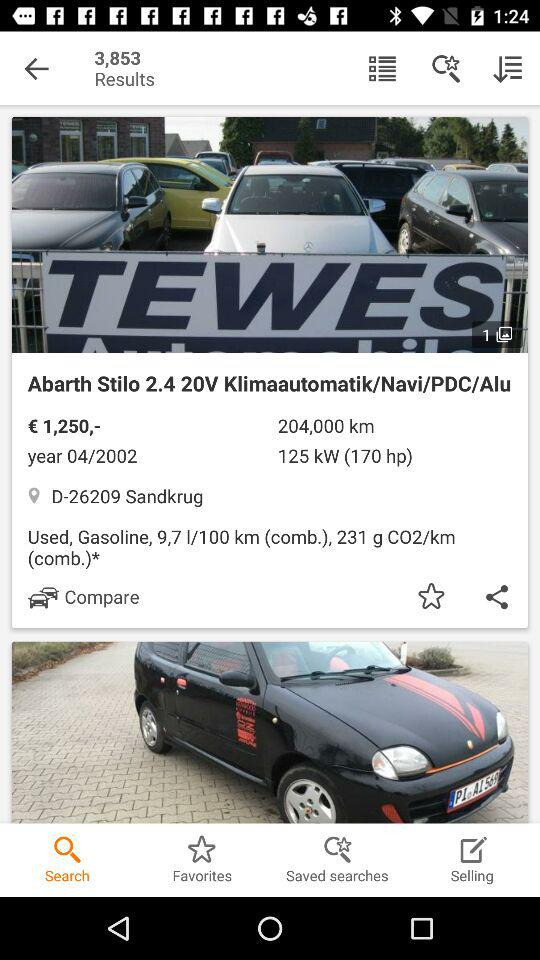What is the address? The address is D-26209 Sandkrug. 